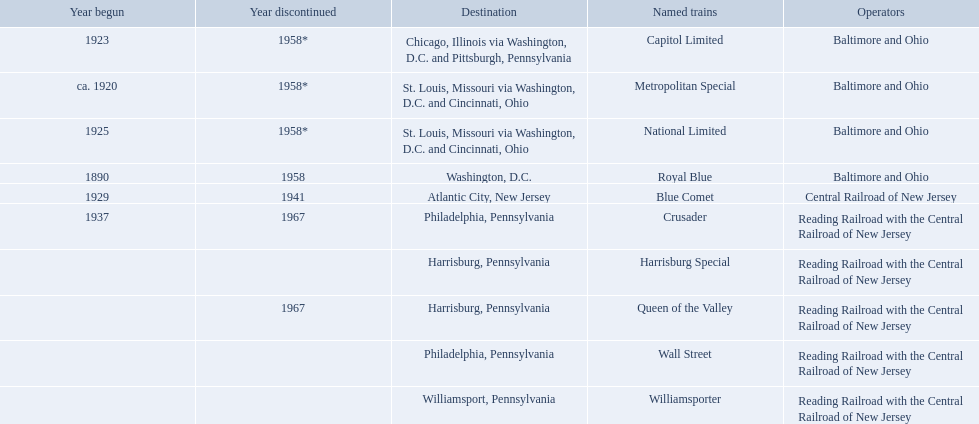Which operators are the reading railroad with the central railroad of new jersey? Reading Railroad with the Central Railroad of New Jersey, Reading Railroad with the Central Railroad of New Jersey, Reading Railroad with the Central Railroad of New Jersey, Reading Railroad with the Central Railroad of New Jersey, Reading Railroad with the Central Railroad of New Jersey. Which destinations are philadelphia, pennsylvania? Philadelphia, Pennsylvania, Philadelphia, Pennsylvania. What on began in 1937? 1937. What is the named train? Crusader. 